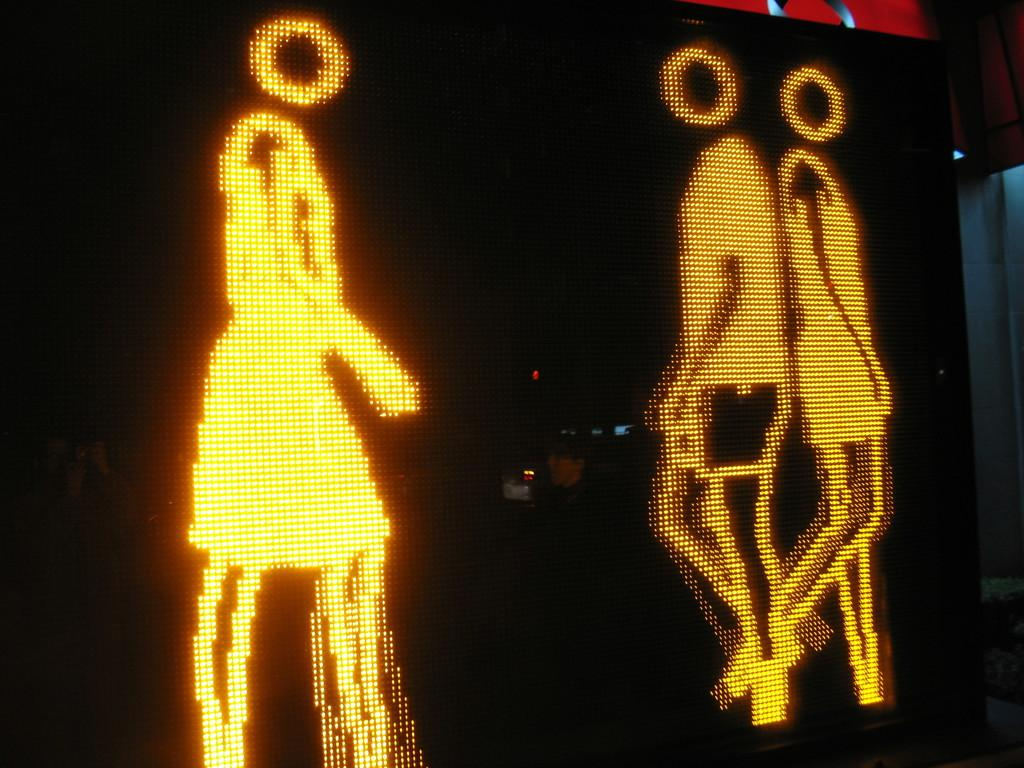What is displayed on the screen in the image? There is an animation of people on the screen in the image. Where is the animation located on the screen? The animation is in the middle of the image. What type of brush is being used by the people in the animation? There is no brush present in the animation; it only shows people. 